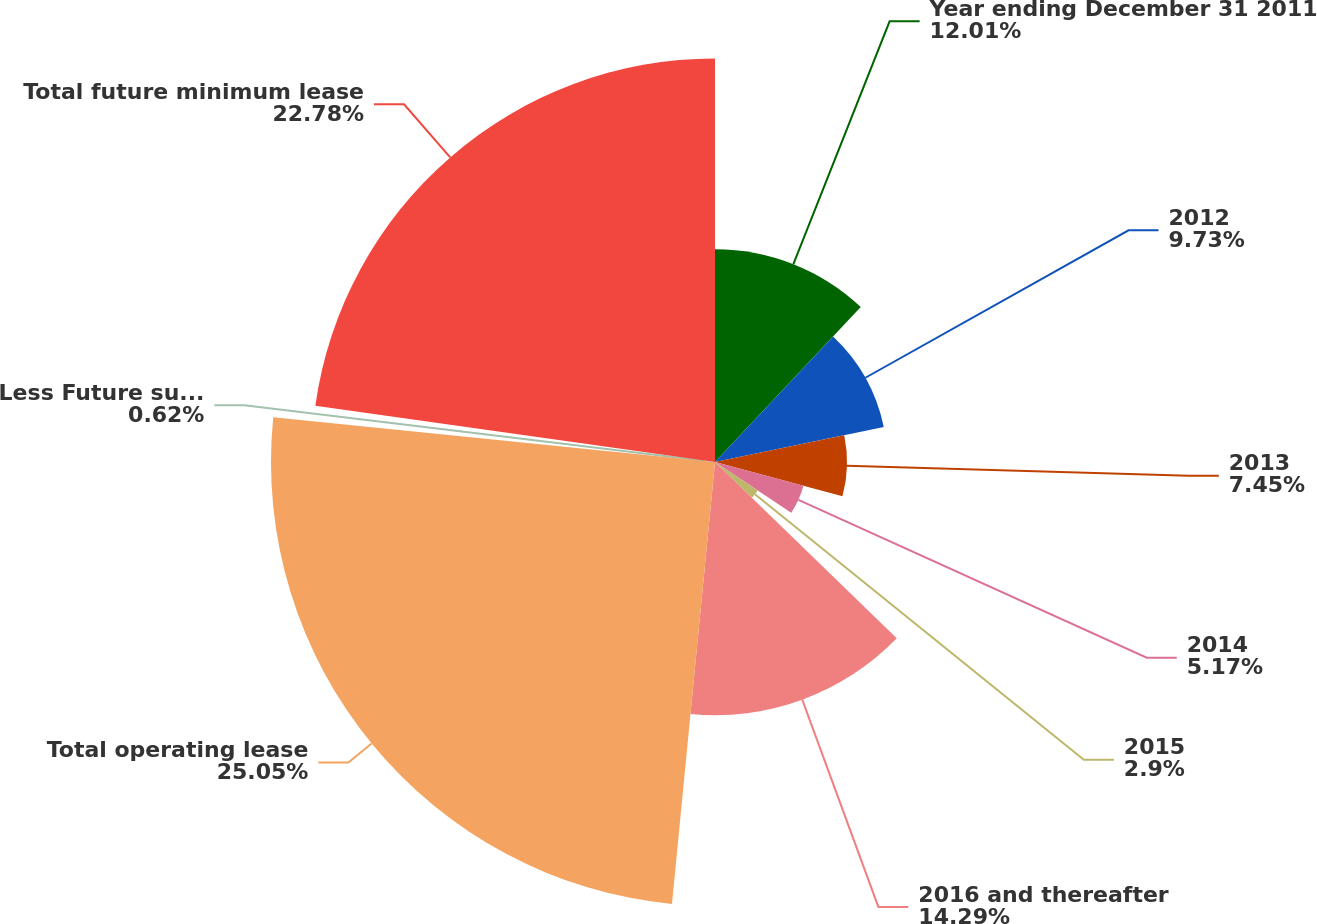<chart> <loc_0><loc_0><loc_500><loc_500><pie_chart><fcel>Year ending December 31 2011<fcel>2012<fcel>2013<fcel>2014<fcel>2015<fcel>2016 and thereafter<fcel>Total operating lease<fcel>Less Future sublease rental<fcel>Total future minimum lease<nl><fcel>12.01%<fcel>9.73%<fcel>7.45%<fcel>5.17%<fcel>2.9%<fcel>14.29%<fcel>25.06%<fcel>0.62%<fcel>22.78%<nl></chart> 